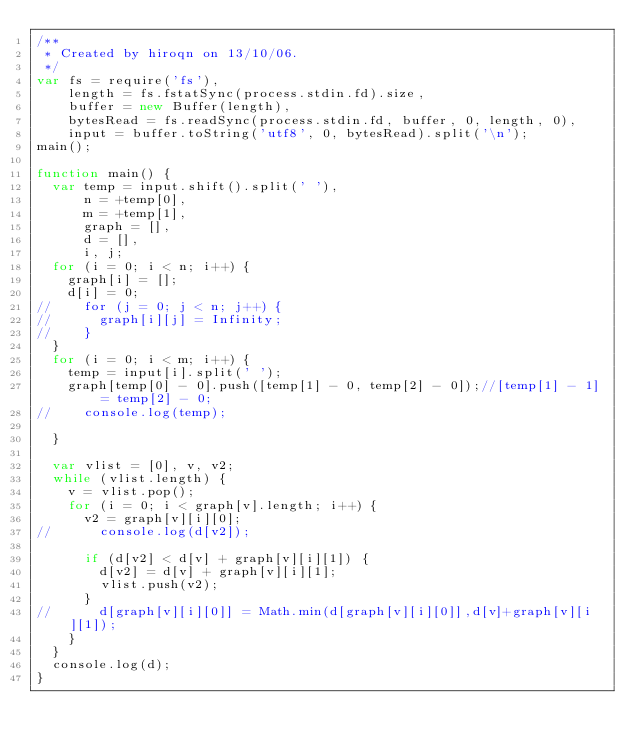<code> <loc_0><loc_0><loc_500><loc_500><_JavaScript_>/**
 * Created by hiroqn on 13/10/06.
 */
var fs = require('fs'),
    length = fs.fstatSync(process.stdin.fd).size,
    buffer = new Buffer(length),
    bytesRead = fs.readSync(process.stdin.fd, buffer, 0, length, 0),
    input = buffer.toString('utf8', 0, bytesRead).split('\n');
main();

function main() {
  var temp = input.shift().split(' '),
      n = +temp[0],
      m = +temp[1],
      graph = [],
      d = [],
      i, j;
  for (i = 0; i < n; i++) {
    graph[i] = [];
    d[i] = 0;
//    for (j = 0; j < n; j++) {
//      graph[i][j] = Infinity;
//    }
  }
  for (i = 0; i < m; i++) {
    temp = input[i].split(' ');
    graph[temp[0] - 0].push([temp[1] - 0, temp[2] - 0]);//[temp[1] - 1] = temp[2] - 0;
//    console.log(temp);

  }

  var vlist = [0], v, v2;
  while (vlist.length) {
    v = vlist.pop();
    for (i = 0; i < graph[v].length; i++) {
      v2 = graph[v][i][0];
//      console.log(d[v2]);

      if (d[v2] < d[v] + graph[v][i][1]) {
        d[v2] = d[v] + graph[v][i][1];
        vlist.push(v2);
      }
//      d[graph[v][i][0]] = Math.min(d[graph[v][i][0]],d[v]+graph[v][i][1]);
    }
  }
  console.log(d);
}</code> 